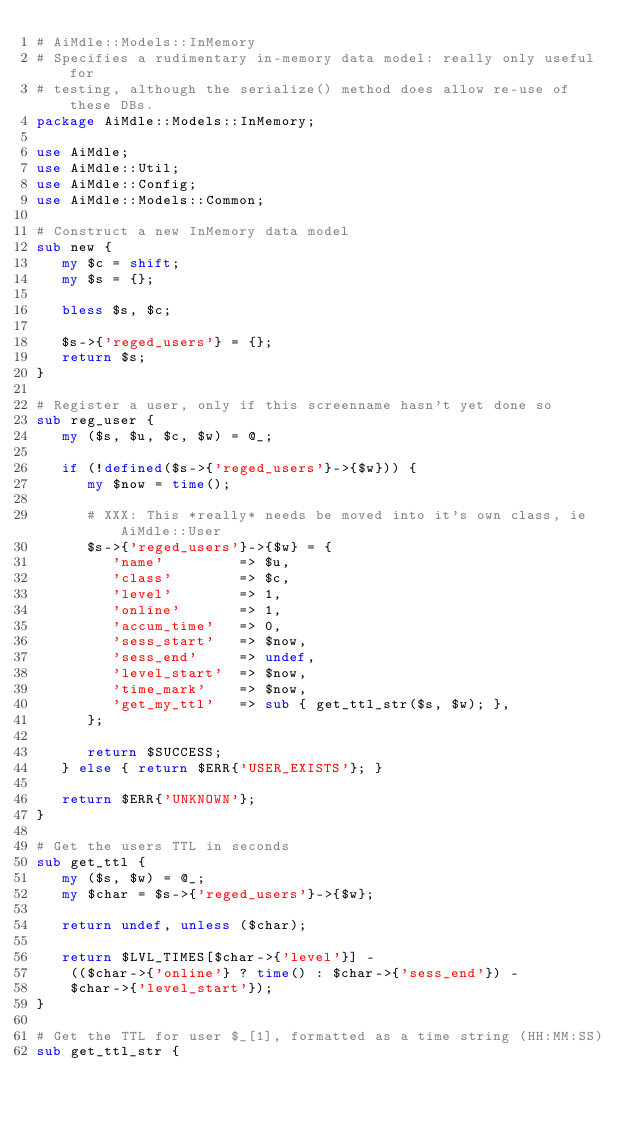<code> <loc_0><loc_0><loc_500><loc_500><_Perl_># AiMdle::Models::InMemory
# Specifies a rudimentary in-memory data model: really only useful for
# testing, although the serialize() method does allow re-use of these DBs.
package AiMdle::Models::InMemory;

use AiMdle;
use AiMdle::Util;
use AiMdle::Config;
use AiMdle::Models::Common;

# Construct a new InMemory data model
sub new {
   my $c = shift;
   my $s = {};

   bless $s, $c;

   $s->{'reged_users'} = {};
   return $s;
}

# Register a user, only if this screenname hasn't yet done so
sub reg_user {
   my ($s, $u, $c, $w) = @_;

   if (!defined($s->{'reged_users'}->{$w})) {
      my $now = time();
      
      # XXX: This *really* needs be moved into it's own class, ie AiMdle::User
      $s->{'reged_users'}->{$w} = { 
         'name'         => $u,
         'class'        => $c, 
         'level'        => 1,
         'online'       => 1,
         'accum_time'   => 0,
         'sess_start'   => $now, 
         'sess_end'     => undef,
         'level_start'  => $now,
         'time_mark'    => $now,
         'get_my_ttl'   => sub { get_ttl_str($s, $w); },
      };
      
      return $SUCCESS;
   } else { return $ERR{'USER_EXISTS'}; }

   return $ERR{'UNKNOWN'};
}

# Get the users TTL in seconds
sub get_ttl {
   my ($s, $w) = @_;
   my $char = $s->{'reged_users'}->{$w};

   return undef, unless ($char);

   return $LVL_TIMES[$char->{'level'}] - 
    (($char->{'online'} ? time() : $char->{'sess_end'}) - 
    $char->{'level_start'});
}

# Get the TTL for user $_[1], formatted as a time string (HH:MM:SS)
sub get_ttl_str {</code> 